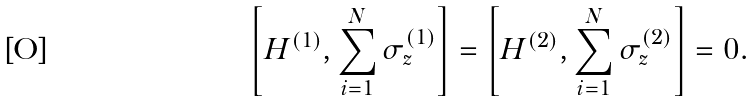Convert formula to latex. <formula><loc_0><loc_0><loc_500><loc_500>\left [ H ^ { ( 1 ) } , \sum _ { i = 1 } ^ { N } \sigma _ { z } ^ { ( 1 ) } \right ] = \left [ H ^ { ( 2 ) } , \sum _ { i = 1 } ^ { N } \sigma _ { z } ^ { ( 2 ) } \right ] = 0 .</formula> 